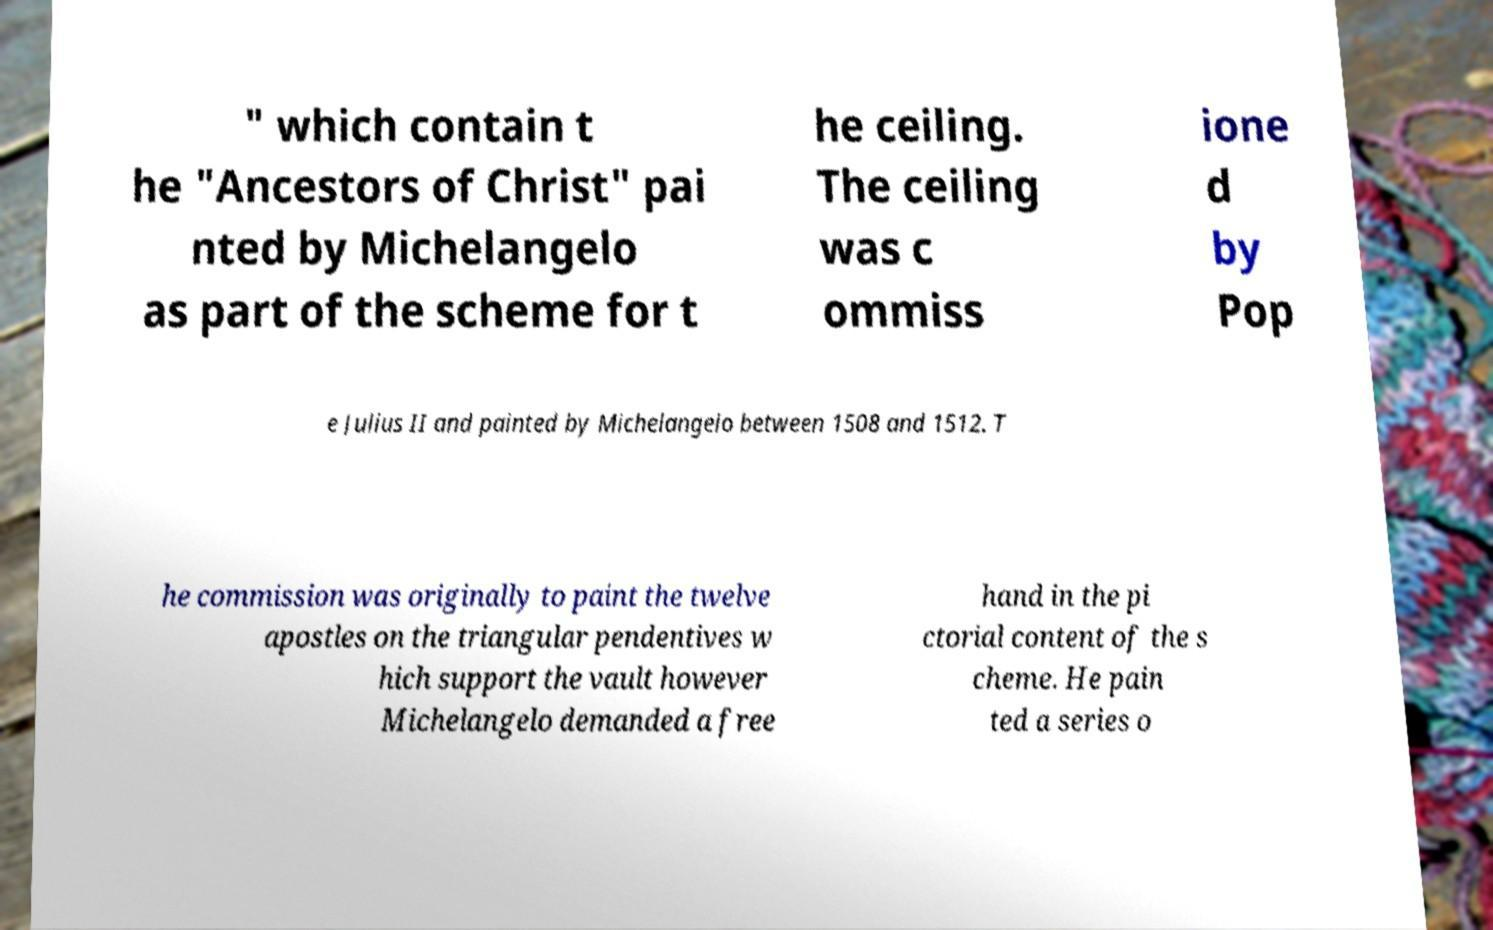Could you assist in decoding the text presented in this image and type it out clearly? " which contain t he "Ancestors of Christ" pai nted by Michelangelo as part of the scheme for t he ceiling. The ceiling was c ommiss ione d by Pop e Julius II and painted by Michelangelo between 1508 and 1512. T he commission was originally to paint the twelve apostles on the triangular pendentives w hich support the vault however Michelangelo demanded a free hand in the pi ctorial content of the s cheme. He pain ted a series o 